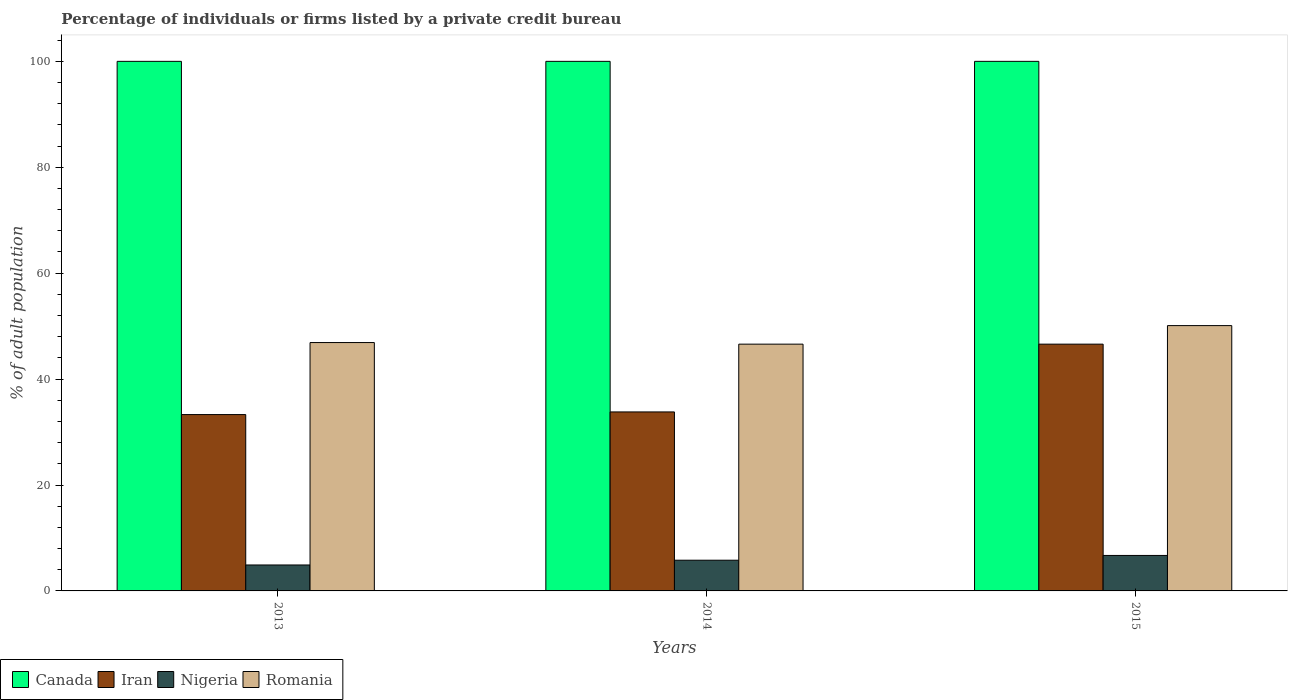How many groups of bars are there?
Your answer should be compact. 3. How many bars are there on the 1st tick from the left?
Offer a terse response. 4. What is the label of the 1st group of bars from the left?
Your response must be concise. 2013. In how many cases, is the number of bars for a given year not equal to the number of legend labels?
Provide a short and direct response. 0. What is the percentage of population listed by a private credit bureau in Canada in 2013?
Provide a short and direct response. 100. Across all years, what is the maximum percentage of population listed by a private credit bureau in Romania?
Provide a succinct answer. 50.1. Across all years, what is the minimum percentage of population listed by a private credit bureau in Canada?
Keep it short and to the point. 100. In which year was the percentage of population listed by a private credit bureau in Romania maximum?
Offer a terse response. 2015. What is the total percentage of population listed by a private credit bureau in Iran in the graph?
Give a very brief answer. 113.7. What is the difference between the percentage of population listed by a private credit bureau in Romania in 2013 and that in 2014?
Your answer should be compact. 0.3. What is the difference between the percentage of population listed by a private credit bureau in Romania in 2014 and the percentage of population listed by a private credit bureau in Nigeria in 2013?
Offer a terse response. 41.7. What is the average percentage of population listed by a private credit bureau in Iran per year?
Your answer should be compact. 37.9. In the year 2014, what is the difference between the percentage of population listed by a private credit bureau in Canada and percentage of population listed by a private credit bureau in Iran?
Offer a very short reply. 66.2. In how many years, is the percentage of population listed by a private credit bureau in Canada greater than 56 %?
Provide a succinct answer. 3. Is the percentage of population listed by a private credit bureau in Nigeria in 2014 less than that in 2015?
Ensure brevity in your answer.  Yes. Is the difference between the percentage of population listed by a private credit bureau in Canada in 2014 and 2015 greater than the difference between the percentage of population listed by a private credit bureau in Iran in 2014 and 2015?
Ensure brevity in your answer.  Yes. What is the difference between the highest and the second highest percentage of population listed by a private credit bureau in Romania?
Provide a succinct answer. 3.2. What is the difference between the highest and the lowest percentage of population listed by a private credit bureau in Iran?
Provide a short and direct response. 13.3. Is it the case that in every year, the sum of the percentage of population listed by a private credit bureau in Iran and percentage of population listed by a private credit bureau in Canada is greater than the sum of percentage of population listed by a private credit bureau in Romania and percentage of population listed by a private credit bureau in Nigeria?
Give a very brief answer. Yes. What does the 4th bar from the left in 2014 represents?
Keep it short and to the point. Romania. What does the 1st bar from the right in 2014 represents?
Keep it short and to the point. Romania. How many bars are there?
Ensure brevity in your answer.  12. Are the values on the major ticks of Y-axis written in scientific E-notation?
Ensure brevity in your answer.  No. Does the graph contain grids?
Keep it short and to the point. No. How are the legend labels stacked?
Your response must be concise. Horizontal. What is the title of the graph?
Offer a very short reply. Percentage of individuals or firms listed by a private credit bureau. What is the label or title of the X-axis?
Your answer should be very brief. Years. What is the label or title of the Y-axis?
Offer a terse response. % of adult population. What is the % of adult population in Iran in 2013?
Make the answer very short. 33.3. What is the % of adult population in Romania in 2013?
Make the answer very short. 46.9. What is the % of adult population of Iran in 2014?
Offer a very short reply. 33.8. What is the % of adult population in Romania in 2014?
Offer a terse response. 46.6. What is the % of adult population of Canada in 2015?
Your answer should be compact. 100. What is the % of adult population of Iran in 2015?
Offer a terse response. 46.6. What is the % of adult population in Romania in 2015?
Give a very brief answer. 50.1. Across all years, what is the maximum % of adult population of Canada?
Make the answer very short. 100. Across all years, what is the maximum % of adult population of Iran?
Provide a short and direct response. 46.6. Across all years, what is the maximum % of adult population in Romania?
Provide a succinct answer. 50.1. Across all years, what is the minimum % of adult population in Iran?
Keep it short and to the point. 33.3. Across all years, what is the minimum % of adult population in Romania?
Your answer should be compact. 46.6. What is the total % of adult population of Canada in the graph?
Keep it short and to the point. 300. What is the total % of adult population of Iran in the graph?
Your answer should be very brief. 113.7. What is the total % of adult population of Romania in the graph?
Provide a short and direct response. 143.6. What is the difference between the % of adult population in Canada in 2013 and that in 2014?
Your answer should be very brief. 0. What is the difference between the % of adult population in Romania in 2013 and that in 2014?
Give a very brief answer. 0.3. What is the difference between the % of adult population of Canada in 2013 and that in 2015?
Provide a short and direct response. 0. What is the difference between the % of adult population of Canada in 2014 and that in 2015?
Offer a very short reply. 0. What is the difference between the % of adult population of Iran in 2014 and that in 2015?
Offer a very short reply. -12.8. What is the difference between the % of adult population in Nigeria in 2014 and that in 2015?
Ensure brevity in your answer.  -0.9. What is the difference between the % of adult population in Romania in 2014 and that in 2015?
Offer a terse response. -3.5. What is the difference between the % of adult population of Canada in 2013 and the % of adult population of Iran in 2014?
Your response must be concise. 66.2. What is the difference between the % of adult population in Canada in 2013 and the % of adult population in Nigeria in 2014?
Keep it short and to the point. 94.2. What is the difference between the % of adult population in Canada in 2013 and the % of adult population in Romania in 2014?
Your answer should be compact. 53.4. What is the difference between the % of adult population in Iran in 2013 and the % of adult population in Nigeria in 2014?
Keep it short and to the point. 27.5. What is the difference between the % of adult population of Nigeria in 2013 and the % of adult population of Romania in 2014?
Provide a short and direct response. -41.7. What is the difference between the % of adult population in Canada in 2013 and the % of adult population in Iran in 2015?
Give a very brief answer. 53.4. What is the difference between the % of adult population in Canada in 2013 and the % of adult population in Nigeria in 2015?
Your response must be concise. 93.3. What is the difference between the % of adult population of Canada in 2013 and the % of adult population of Romania in 2015?
Your answer should be compact. 49.9. What is the difference between the % of adult population of Iran in 2013 and the % of adult population of Nigeria in 2015?
Provide a succinct answer. 26.6. What is the difference between the % of adult population of Iran in 2013 and the % of adult population of Romania in 2015?
Make the answer very short. -16.8. What is the difference between the % of adult population in Nigeria in 2013 and the % of adult population in Romania in 2015?
Offer a very short reply. -45.2. What is the difference between the % of adult population of Canada in 2014 and the % of adult population of Iran in 2015?
Keep it short and to the point. 53.4. What is the difference between the % of adult population in Canada in 2014 and the % of adult population in Nigeria in 2015?
Your response must be concise. 93.3. What is the difference between the % of adult population of Canada in 2014 and the % of adult population of Romania in 2015?
Keep it short and to the point. 49.9. What is the difference between the % of adult population of Iran in 2014 and the % of adult population of Nigeria in 2015?
Give a very brief answer. 27.1. What is the difference between the % of adult population of Iran in 2014 and the % of adult population of Romania in 2015?
Keep it short and to the point. -16.3. What is the difference between the % of adult population of Nigeria in 2014 and the % of adult population of Romania in 2015?
Your answer should be compact. -44.3. What is the average % of adult population in Iran per year?
Offer a very short reply. 37.9. What is the average % of adult population in Romania per year?
Offer a very short reply. 47.87. In the year 2013, what is the difference between the % of adult population of Canada and % of adult population of Iran?
Offer a very short reply. 66.7. In the year 2013, what is the difference between the % of adult population of Canada and % of adult population of Nigeria?
Ensure brevity in your answer.  95.1. In the year 2013, what is the difference between the % of adult population in Canada and % of adult population in Romania?
Make the answer very short. 53.1. In the year 2013, what is the difference between the % of adult population of Iran and % of adult population of Nigeria?
Keep it short and to the point. 28.4. In the year 2013, what is the difference between the % of adult population of Iran and % of adult population of Romania?
Your answer should be very brief. -13.6. In the year 2013, what is the difference between the % of adult population of Nigeria and % of adult population of Romania?
Make the answer very short. -42. In the year 2014, what is the difference between the % of adult population of Canada and % of adult population of Iran?
Offer a very short reply. 66.2. In the year 2014, what is the difference between the % of adult population in Canada and % of adult population in Nigeria?
Ensure brevity in your answer.  94.2. In the year 2014, what is the difference between the % of adult population of Canada and % of adult population of Romania?
Ensure brevity in your answer.  53.4. In the year 2014, what is the difference between the % of adult population in Iran and % of adult population in Nigeria?
Offer a very short reply. 28. In the year 2014, what is the difference between the % of adult population in Nigeria and % of adult population in Romania?
Provide a succinct answer. -40.8. In the year 2015, what is the difference between the % of adult population in Canada and % of adult population in Iran?
Your answer should be very brief. 53.4. In the year 2015, what is the difference between the % of adult population of Canada and % of adult population of Nigeria?
Offer a very short reply. 93.3. In the year 2015, what is the difference between the % of adult population in Canada and % of adult population in Romania?
Ensure brevity in your answer.  49.9. In the year 2015, what is the difference between the % of adult population in Iran and % of adult population in Nigeria?
Provide a succinct answer. 39.9. In the year 2015, what is the difference between the % of adult population in Nigeria and % of adult population in Romania?
Your answer should be very brief. -43.4. What is the ratio of the % of adult population of Canada in 2013 to that in 2014?
Offer a terse response. 1. What is the ratio of the % of adult population in Iran in 2013 to that in 2014?
Ensure brevity in your answer.  0.99. What is the ratio of the % of adult population in Nigeria in 2013 to that in 2014?
Your response must be concise. 0.84. What is the ratio of the % of adult population in Romania in 2013 to that in 2014?
Provide a short and direct response. 1.01. What is the ratio of the % of adult population in Iran in 2013 to that in 2015?
Keep it short and to the point. 0.71. What is the ratio of the % of adult population of Nigeria in 2013 to that in 2015?
Your answer should be compact. 0.73. What is the ratio of the % of adult population of Romania in 2013 to that in 2015?
Provide a short and direct response. 0.94. What is the ratio of the % of adult population in Canada in 2014 to that in 2015?
Offer a terse response. 1. What is the ratio of the % of adult population in Iran in 2014 to that in 2015?
Provide a short and direct response. 0.73. What is the ratio of the % of adult population in Nigeria in 2014 to that in 2015?
Ensure brevity in your answer.  0.87. What is the ratio of the % of adult population of Romania in 2014 to that in 2015?
Your answer should be compact. 0.93. What is the difference between the highest and the second highest % of adult population of Iran?
Provide a succinct answer. 12.8. What is the difference between the highest and the second highest % of adult population of Nigeria?
Offer a very short reply. 0.9. What is the difference between the highest and the second highest % of adult population in Romania?
Provide a succinct answer. 3.2. What is the difference between the highest and the lowest % of adult population of Iran?
Ensure brevity in your answer.  13.3. 